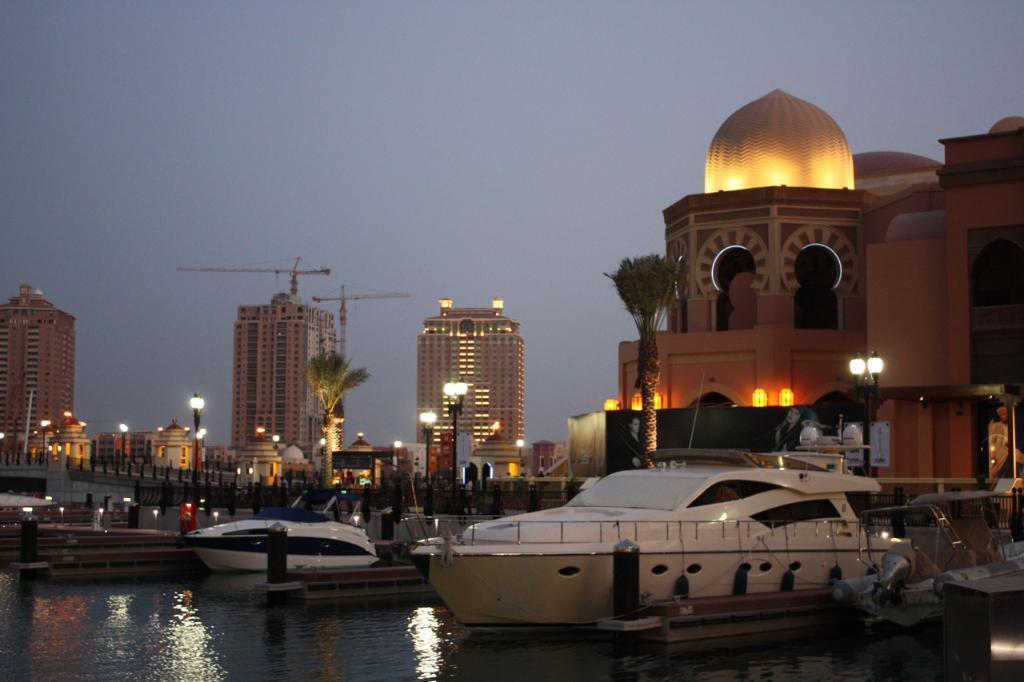Please provide a concise description of this image. This is an outside view. At the bottom there are two boats on the water. In the background there are many lights poles, trees and buildings. On the left side there are two cranes behind the building. At the top of the image I can see the sky. 